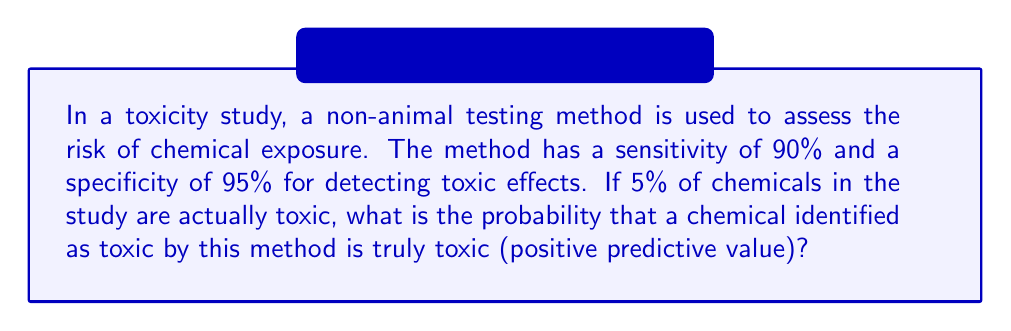Solve this math problem. To solve this problem, we'll use Bayes' theorem. Let's define our events:

T: The chemical is truly toxic
P: The test result is positive (indicates toxicity)

We're given:
$P(T) = 0.05$ (5% of chemicals are toxic)
$P(P|T) = 0.90$ (sensitivity)
$P(P|\neg T) = 1 - 0.95 = 0.05$ (1 - specificity)

We want to find $P(T|P)$, the positive predictive value.

Bayes' theorem states:

$$ P(T|P) = \frac{P(P|T) \cdot P(T)}{P(P)} $$

To find $P(P)$, we use the law of total probability:

$$ P(P) = P(P|T) \cdot P(T) + P(P|\neg T) \cdot P(\neg T) $$

Step 1: Calculate $P(\neg T)$
$P(\neg T) = 1 - P(T) = 1 - 0.05 = 0.95$

Step 2: Calculate $P(P)$
$P(P) = 0.90 \cdot 0.05 + 0.05 \cdot 0.95 = 0.045 + 0.0475 = 0.0925$

Step 3: Apply Bayes' theorem
$$ P(T|P) = \frac{0.90 \cdot 0.05}{0.0925} = \frac{0.045}{0.0925} \approx 0.4865 $$

Therefore, the probability that a chemical identified as toxic is truly toxic is approximately 0.4865 or 48.65%.
Answer: 0.4865 